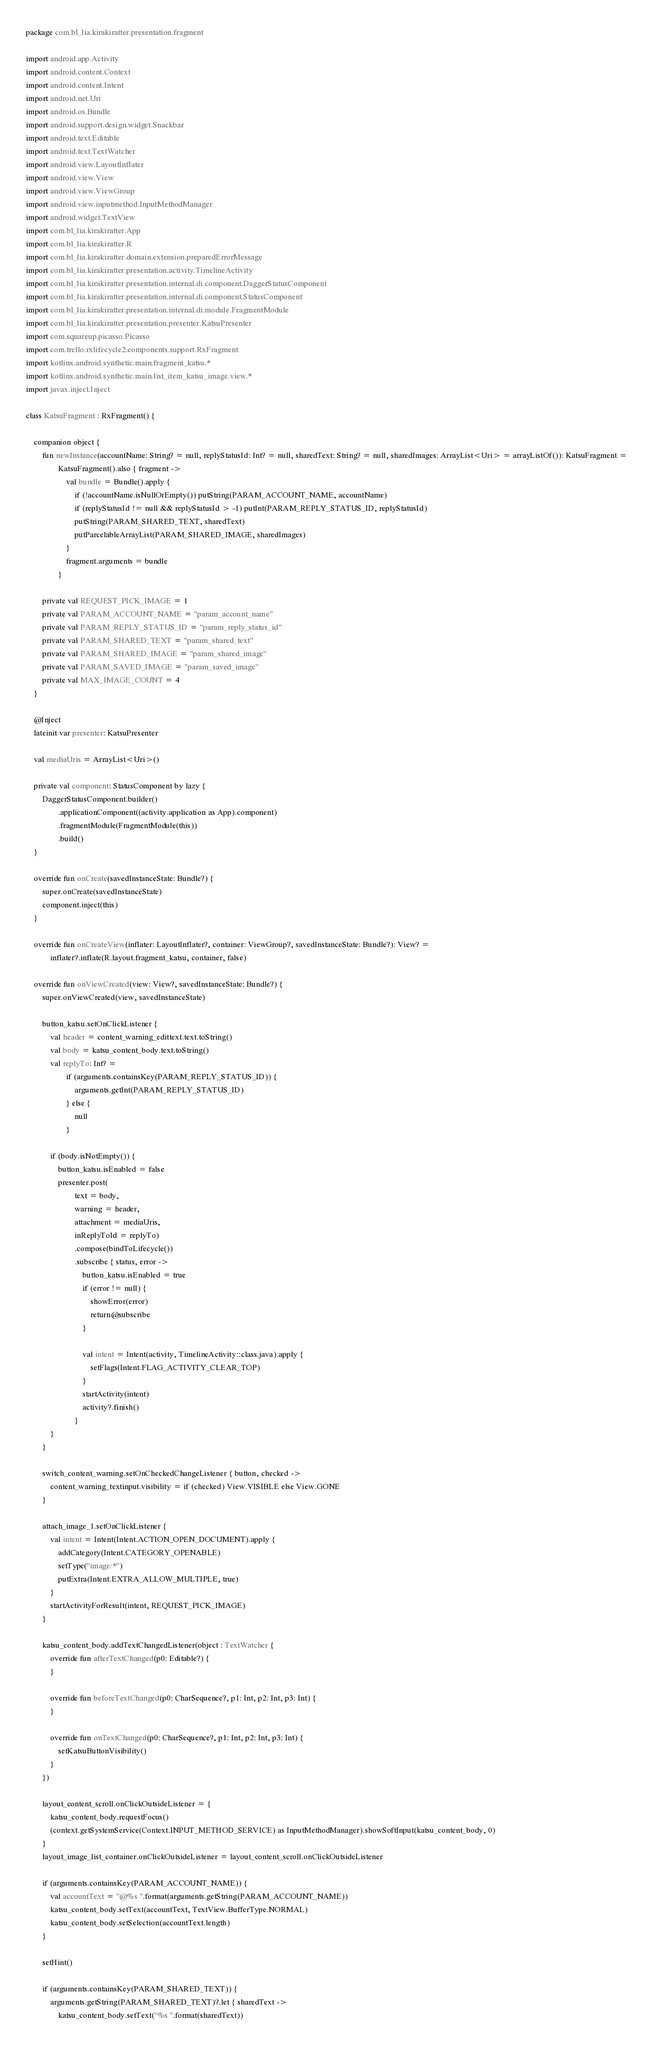<code> <loc_0><loc_0><loc_500><loc_500><_Kotlin_>package com.bl_lia.kirakiratter.presentation.fragment

import android.app.Activity
import android.content.Context
import android.content.Intent
import android.net.Uri
import android.os.Bundle
import android.support.design.widget.Snackbar
import android.text.Editable
import android.text.TextWatcher
import android.view.LayoutInflater
import android.view.View
import android.view.ViewGroup
import android.view.inputmethod.InputMethodManager
import android.widget.TextView
import com.bl_lia.kirakiratter.App
import com.bl_lia.kirakiratter.R
import com.bl_lia.kirakiratter.domain.extension.preparedErrorMessage
import com.bl_lia.kirakiratter.presentation.activity.TimelineActivity
import com.bl_lia.kirakiratter.presentation.internal.di.component.DaggerStatusComponent
import com.bl_lia.kirakiratter.presentation.internal.di.component.StatusComponent
import com.bl_lia.kirakiratter.presentation.internal.di.module.FragmentModule
import com.bl_lia.kirakiratter.presentation.presenter.KatsuPresenter
import com.squareup.picasso.Picasso
import com.trello.rxlifecycle2.components.support.RxFragment
import kotlinx.android.synthetic.main.fragment_katsu.*
import kotlinx.android.synthetic.main.list_item_katsu_image.view.*
import javax.inject.Inject

class KatsuFragment : RxFragment() {

    companion object {
        fun newInstance(accountName: String? = null, replyStatusId: Int? = null, sharedText: String? = null, sharedImages: ArrayList<Uri> = arrayListOf()): KatsuFragment =
                KatsuFragment().also { fragment ->
                    val bundle = Bundle().apply {
                        if (!accountName.isNullOrEmpty()) putString(PARAM_ACCOUNT_NAME, accountName)
                        if (replyStatusId != null && replyStatusId > -1) putInt(PARAM_REPLY_STATUS_ID, replyStatusId)
                        putString(PARAM_SHARED_TEXT, sharedText)
                        putParcelableArrayList(PARAM_SHARED_IMAGE, sharedImages)
                    }
                    fragment.arguments = bundle
                }

        private val REQUEST_PICK_IMAGE = 1
        private val PARAM_ACCOUNT_NAME = "param_account_name"
        private val PARAM_REPLY_STATUS_ID = "param_reply_status_id"
        private val PARAM_SHARED_TEXT = "param_shared_text"
        private val PARAM_SHARED_IMAGE = "param_shared_image"
        private val PARAM_SAVED_IMAGE = "param_saved_image"
        private val MAX_IMAGE_COUNT = 4
    }

    @Inject
    lateinit var presenter: KatsuPresenter

    val mediaUris = ArrayList<Uri>()

    private val component: StatusComponent by lazy {
        DaggerStatusComponent.builder()
                .applicationComponent((activity.application as App).component)
                .fragmentModule(FragmentModule(this))
                .build()
    }

    override fun onCreate(savedInstanceState: Bundle?) {
        super.onCreate(savedInstanceState)
        component.inject(this)
    }

    override fun onCreateView(inflater: LayoutInflater?, container: ViewGroup?, savedInstanceState: Bundle?): View? =
            inflater?.inflate(R.layout.fragment_katsu, container, false)

    override fun onViewCreated(view: View?, savedInstanceState: Bundle?) {
        super.onViewCreated(view, savedInstanceState)

        button_katsu.setOnClickListener {
            val header = content_warning_edittext.text.toString()
            val body = katsu_content_body.text.toString()
            val replyTo: Int? =
                    if (arguments.containsKey(PARAM_REPLY_STATUS_ID)) {
                        arguments.getInt(PARAM_REPLY_STATUS_ID)
                    } else {
                        null
                    }

            if (body.isNotEmpty()) {
                button_katsu.isEnabled = false
                presenter.post(
                        text = body,
                        warning = header,
                        attachment = mediaUris,
                        inReplyToId = replyTo)
                        .compose(bindToLifecycle())
                        .subscribe { status, error ->
                            button_katsu.isEnabled = true
                            if (error != null) {
                                showError(error)
                                return@subscribe
                            }

                            val intent = Intent(activity, TimelineActivity::class.java).apply {
                                setFlags(Intent.FLAG_ACTIVITY_CLEAR_TOP)
                            }
                            startActivity(intent)
                            activity?.finish()
                        }
            }
        }

        switch_content_warning.setOnCheckedChangeListener { button, checked ->
            content_warning_textinput.visibility = if (checked) View.VISIBLE else View.GONE
        }

        attach_image_1.setOnClickListener {
            val intent = Intent(Intent.ACTION_OPEN_DOCUMENT).apply {
                addCategory(Intent.CATEGORY_OPENABLE)
                setType("image/*")
                putExtra(Intent.EXTRA_ALLOW_MULTIPLE, true)
            }
            startActivityForResult(intent, REQUEST_PICK_IMAGE)
        }

        katsu_content_body.addTextChangedListener(object : TextWatcher {
            override fun afterTextChanged(p0: Editable?) {
            }

            override fun beforeTextChanged(p0: CharSequence?, p1: Int, p2: Int, p3: Int) {
            }

            override fun onTextChanged(p0: CharSequence?, p1: Int, p2: Int, p3: Int) {
                setKatsuButtonVisibility()
            }
        })

        layout_content_scroll.onClickOutsideListener = {
            katsu_content_body.requestFocus()
            (context.getSystemService(Context.INPUT_METHOD_SERVICE) as InputMethodManager).showSoftInput(katsu_content_body, 0)
        }
        layout_image_list_container.onClickOutsideListener = layout_content_scroll.onClickOutsideListener

        if (arguments.containsKey(PARAM_ACCOUNT_NAME)) {
            val accountText = "@%s ".format(arguments.getString(PARAM_ACCOUNT_NAME))
            katsu_content_body.setText(accountText, TextView.BufferType.NORMAL)
            katsu_content_body.setSelection(accountText.length)
        }

        setHint()

        if (arguments.containsKey(PARAM_SHARED_TEXT)) {
            arguments.getString(PARAM_SHARED_TEXT)?.let { sharedText ->
                katsu_content_body.setText("%s ".format(sharedText))</code> 